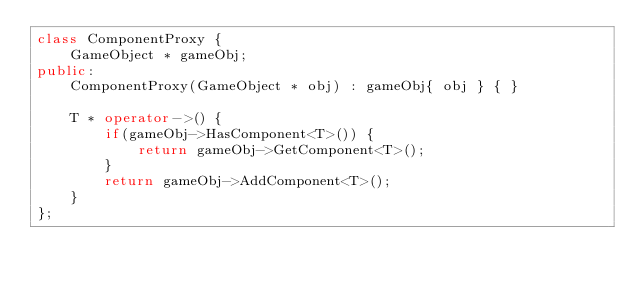Convert code to text. <code><loc_0><loc_0><loc_500><loc_500><_C++_>class ComponentProxy {
	GameObject * gameObj;
public:
	ComponentProxy(GameObject * obj) : gameObj{ obj } { }

	T * operator->() {
		if(gameObj->HasComponent<T>()) {
			return gameObj->GetComponent<T>();
		}
		return gameObj->AddComponent<T>();
	}
};
</code> 